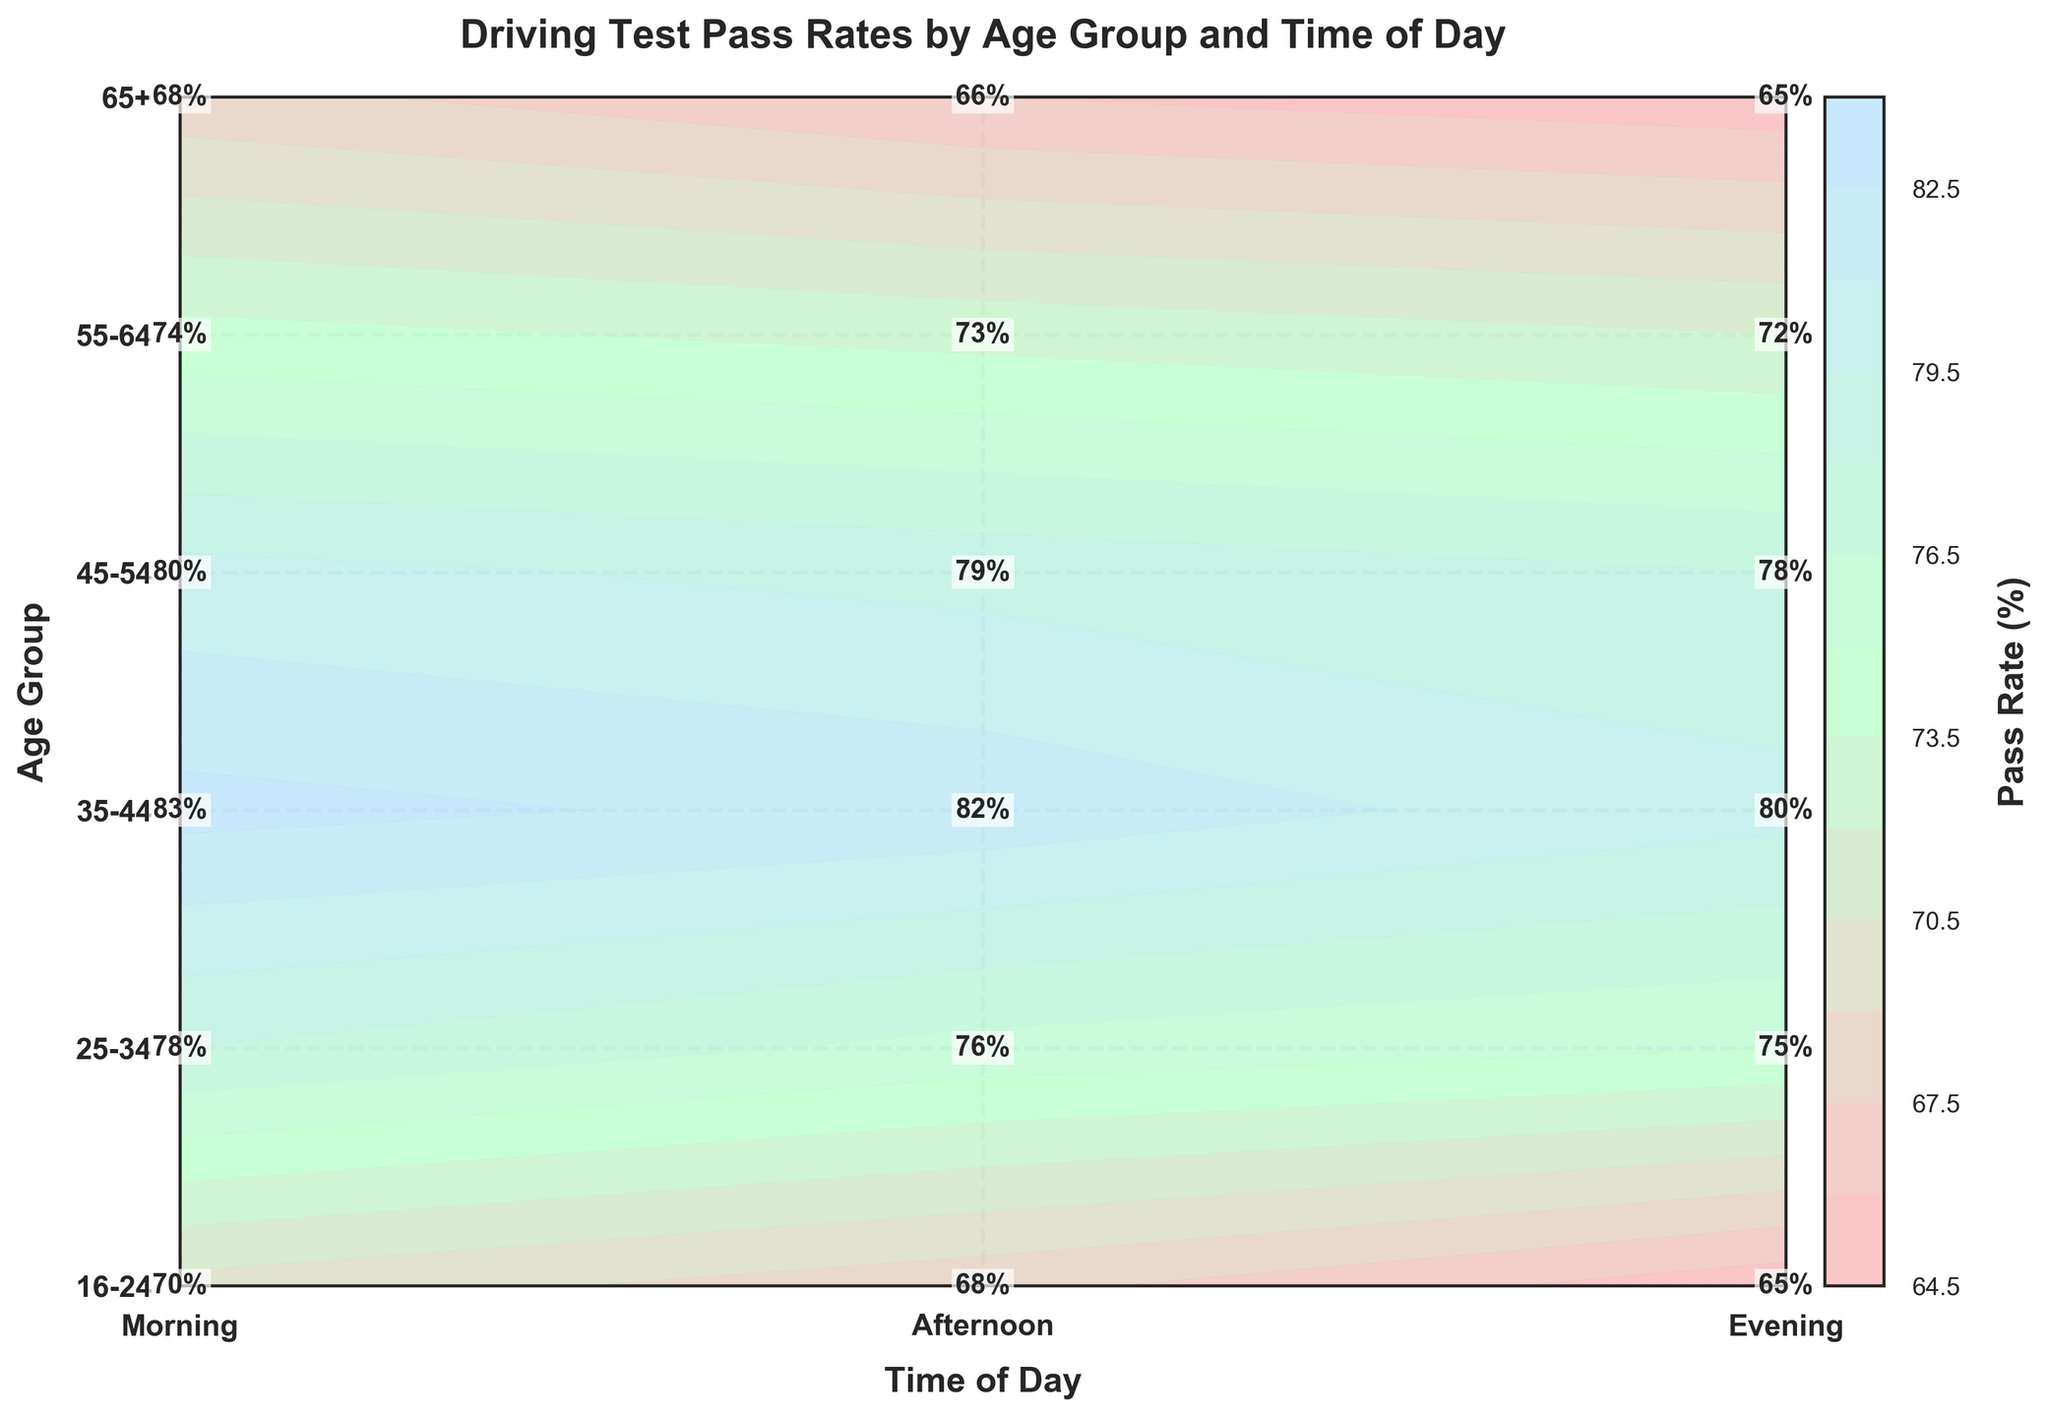What is the title of the figure? The title is displayed at the top of the plot, providing an overview of the data presented.
Answer: Driving Test Pass Rates by Age Group and Time of Day What is the pass rate for the age group 16-24 in the morning? Locate the "16-24" row and follow it to the "Morning" column to find the intersecting cell value.
Answer: 65% Which age group has the highest pass rate in the evening? Locate the "Evening" column and find the highest value, then trace it to the corresponding age group row.
Answer: 35-44 What is the average pass rate for the age group 55-64 across all times of the day? Sum the pass rates for Morning, Afternoon, and Evening for the age group 55-64, then divide by 3: (72 + 74 + 73) / 3
Answer: 73% Is the pass rate for the age group 25-34 higher in the morning or the afternoon? Compare the values for the age group 25-34 in the "Morning" and "Afternoon" columns.
Answer: Afternoon Which time of day generally has the highest pass rates across all age groups? Compare the average pass rates for Morning, Afternoon, and Evening by summing each column’s values and comparing the totals.
Answer: Afternoon How does the pass rate for the age group 65+ in the afternoon compare to that in the morning? Subtract the morning pass rate from the afternoon pass rate for 65+: 68 - 65
Answer: 3% higher What is the difference in pass rates between the age groups 35-44 and 45-54 in the afternoon? Subtract the pass rate for 45-54 from 35-44 in the afternoon: 83 - 80
Answer: 3% What is the median pass rate for the age group 16-24 across different times of the day? Arrange the pass rates for 16-24 (65, 70, 68) and find the middle value.
Answer: 68% Which has the lowest pass rate: age group 16-24 in the evening or age group 65+ in the evening? Compare the pass rates of 16-24 and 65+ in the evening.
Answer: 65+ 